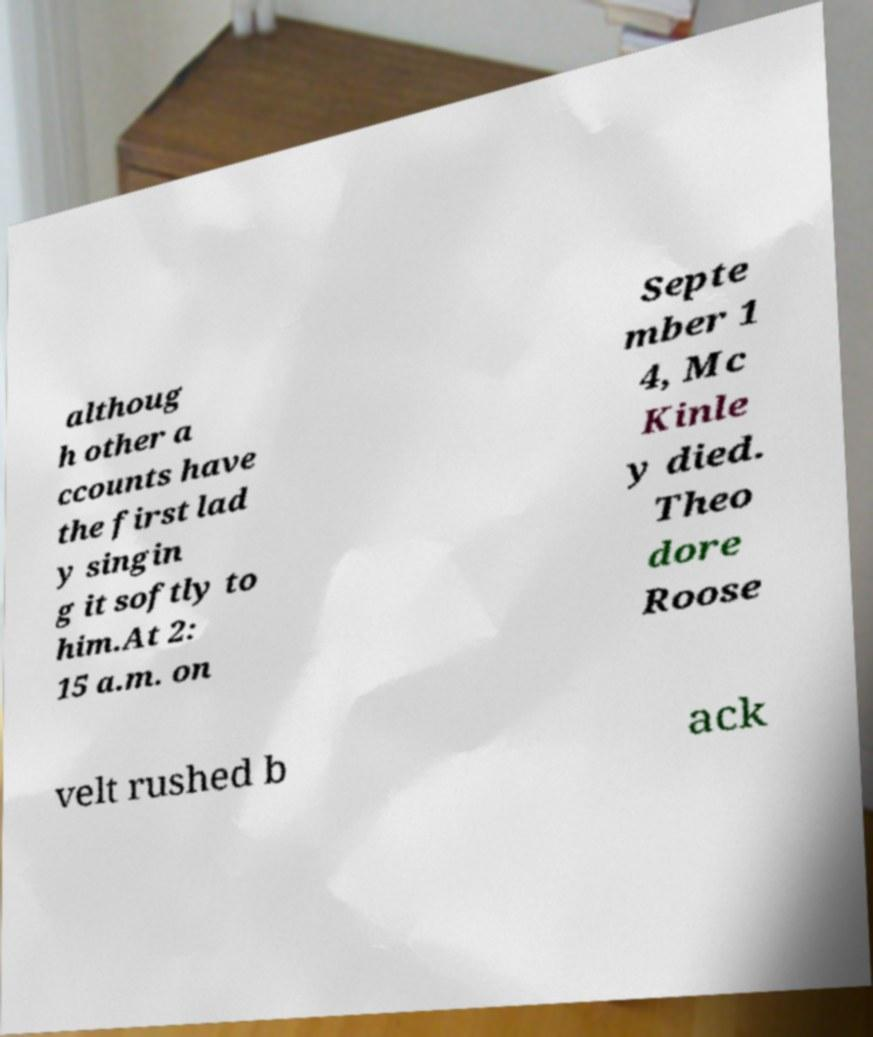Can you accurately transcribe the text from the provided image for me? althoug h other a ccounts have the first lad y singin g it softly to him.At 2: 15 a.m. on Septe mber 1 4, Mc Kinle y died. Theo dore Roose velt rushed b ack 